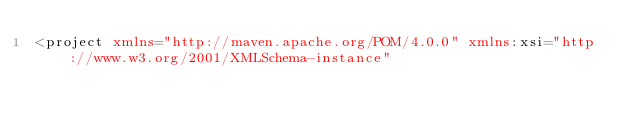Convert code to text. <code><loc_0><loc_0><loc_500><loc_500><_XML_><project xmlns="http://maven.apache.org/POM/4.0.0" xmlns:xsi="http://www.w3.org/2001/XMLSchema-instance"</code> 